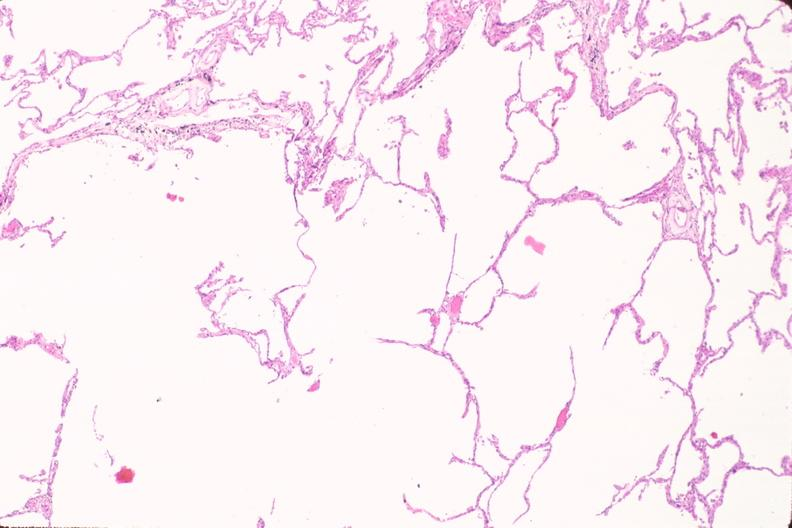does histoplasmosis show lung, emphysema in a chronic smoker?
Answer the question using a single word or phrase. No 